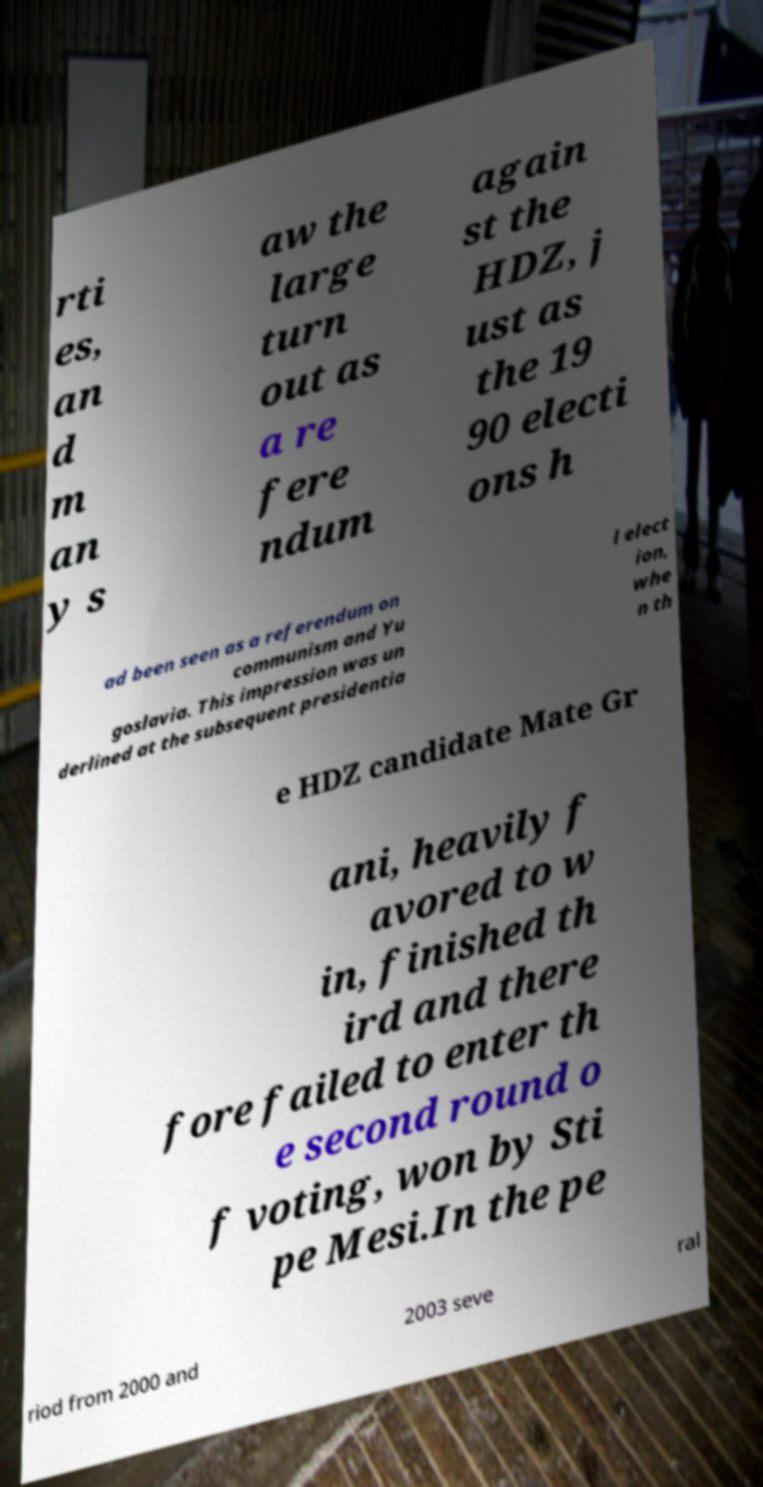What messages or text are displayed in this image? I need them in a readable, typed format. rti es, an d m an y s aw the large turn out as a re fere ndum again st the HDZ, j ust as the 19 90 electi ons h ad been seen as a referendum on communism and Yu goslavia. This impression was un derlined at the subsequent presidentia l elect ion, whe n th e HDZ candidate Mate Gr ani, heavily f avored to w in, finished th ird and there fore failed to enter th e second round o f voting, won by Sti pe Mesi.In the pe riod from 2000 and 2003 seve ral 